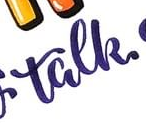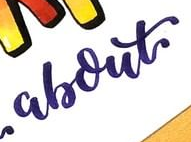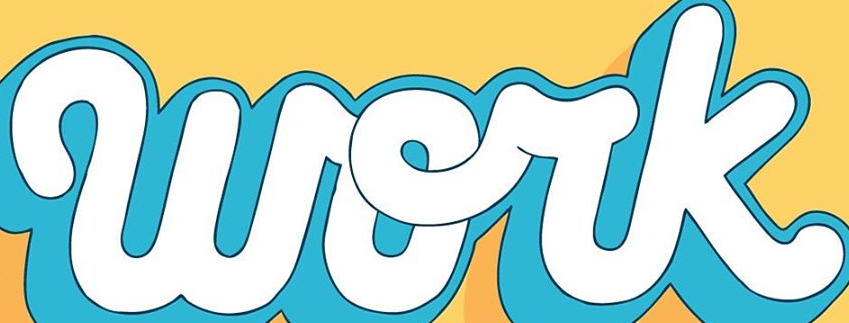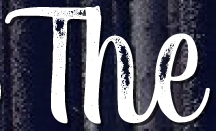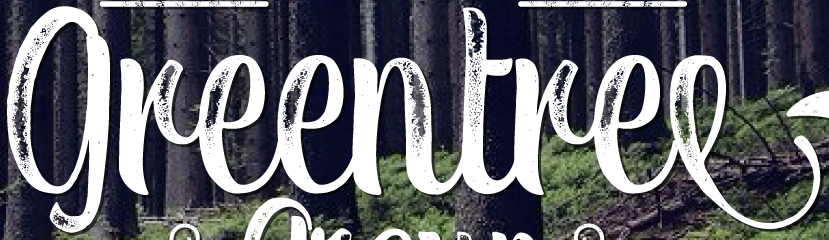Read the text content from these images in order, separated by a semicolon. talk; about; work; The; greentree 